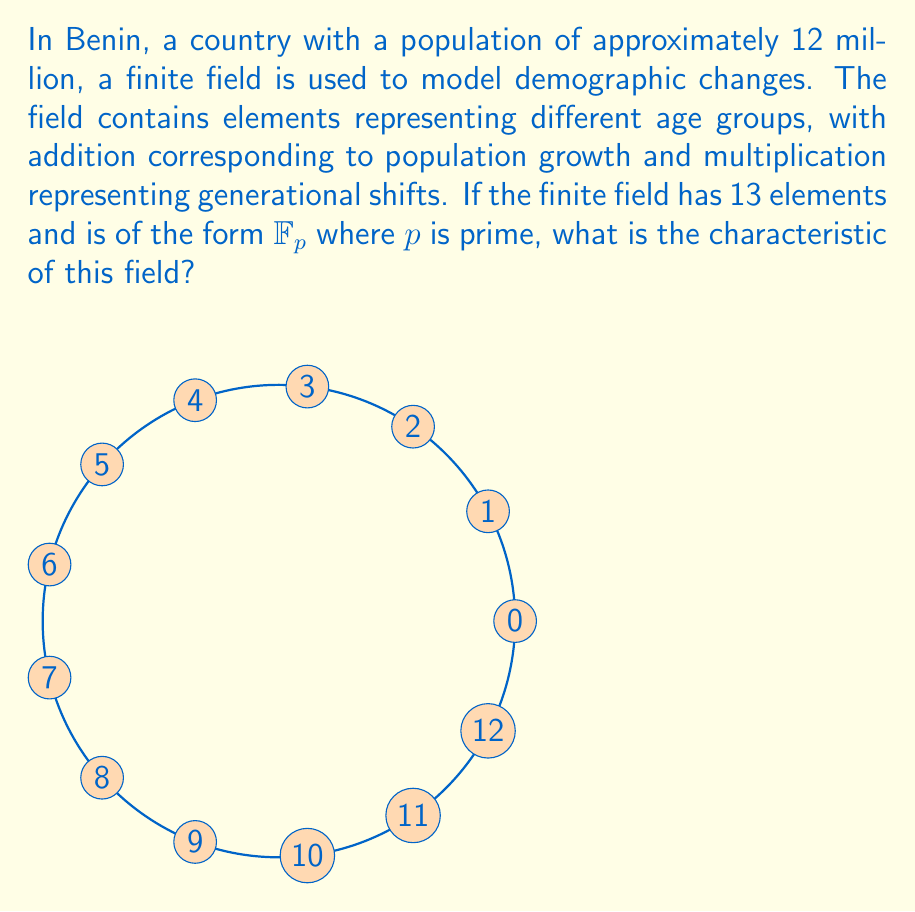What is the answer to this math problem? To find the characteristic of the finite field, we need to follow these steps:

1) The characteristic of a field is the smallest positive integer $n$ such that $n \cdot 1 = 0$ in the field, where $1$ is the multiplicative identity.

2) In a finite field of the form $\mathbb{F}_p$ where $p$ is prime, the characteristic is always equal to $p$.

3) We're given that the field has 13 elements. In a finite field, the number of elements is always a power of a prime number.

4) Since 13 is itself a prime number, we know that this field is $\mathbb{F}_{13}$.

5) Therefore, the characteristic of this field is 13.

This means that in this demographic model, adding any age group to itself 13 times will result in the zero element, representing a full cycle in the population model.
Answer: 13 